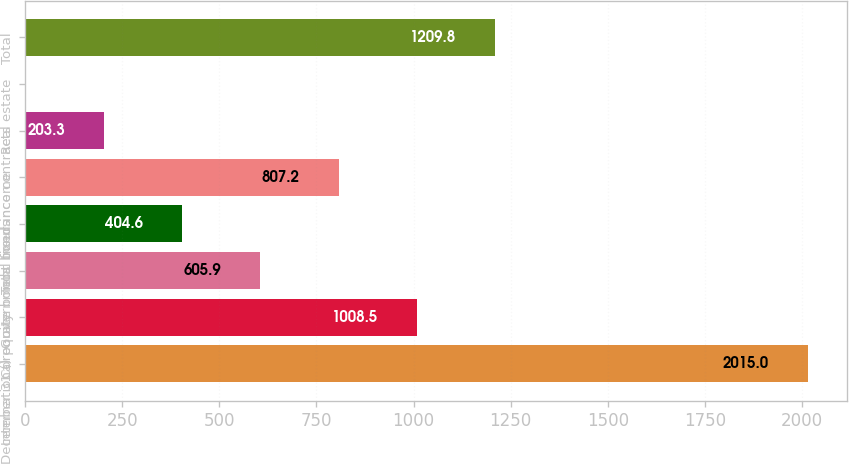Convert chart. <chart><loc_0><loc_0><loc_500><loc_500><bar_chart><fcel>December 31 ()<fcel>International equity<fcel>Corporate bonds<fcel>Government bonds<fcel>Total fixed income<fcel>Insurance contracts<fcel>Real estate<fcel>Total<nl><fcel>2015<fcel>1008.5<fcel>605.9<fcel>404.6<fcel>807.2<fcel>203.3<fcel>2<fcel>1209.8<nl></chart> 